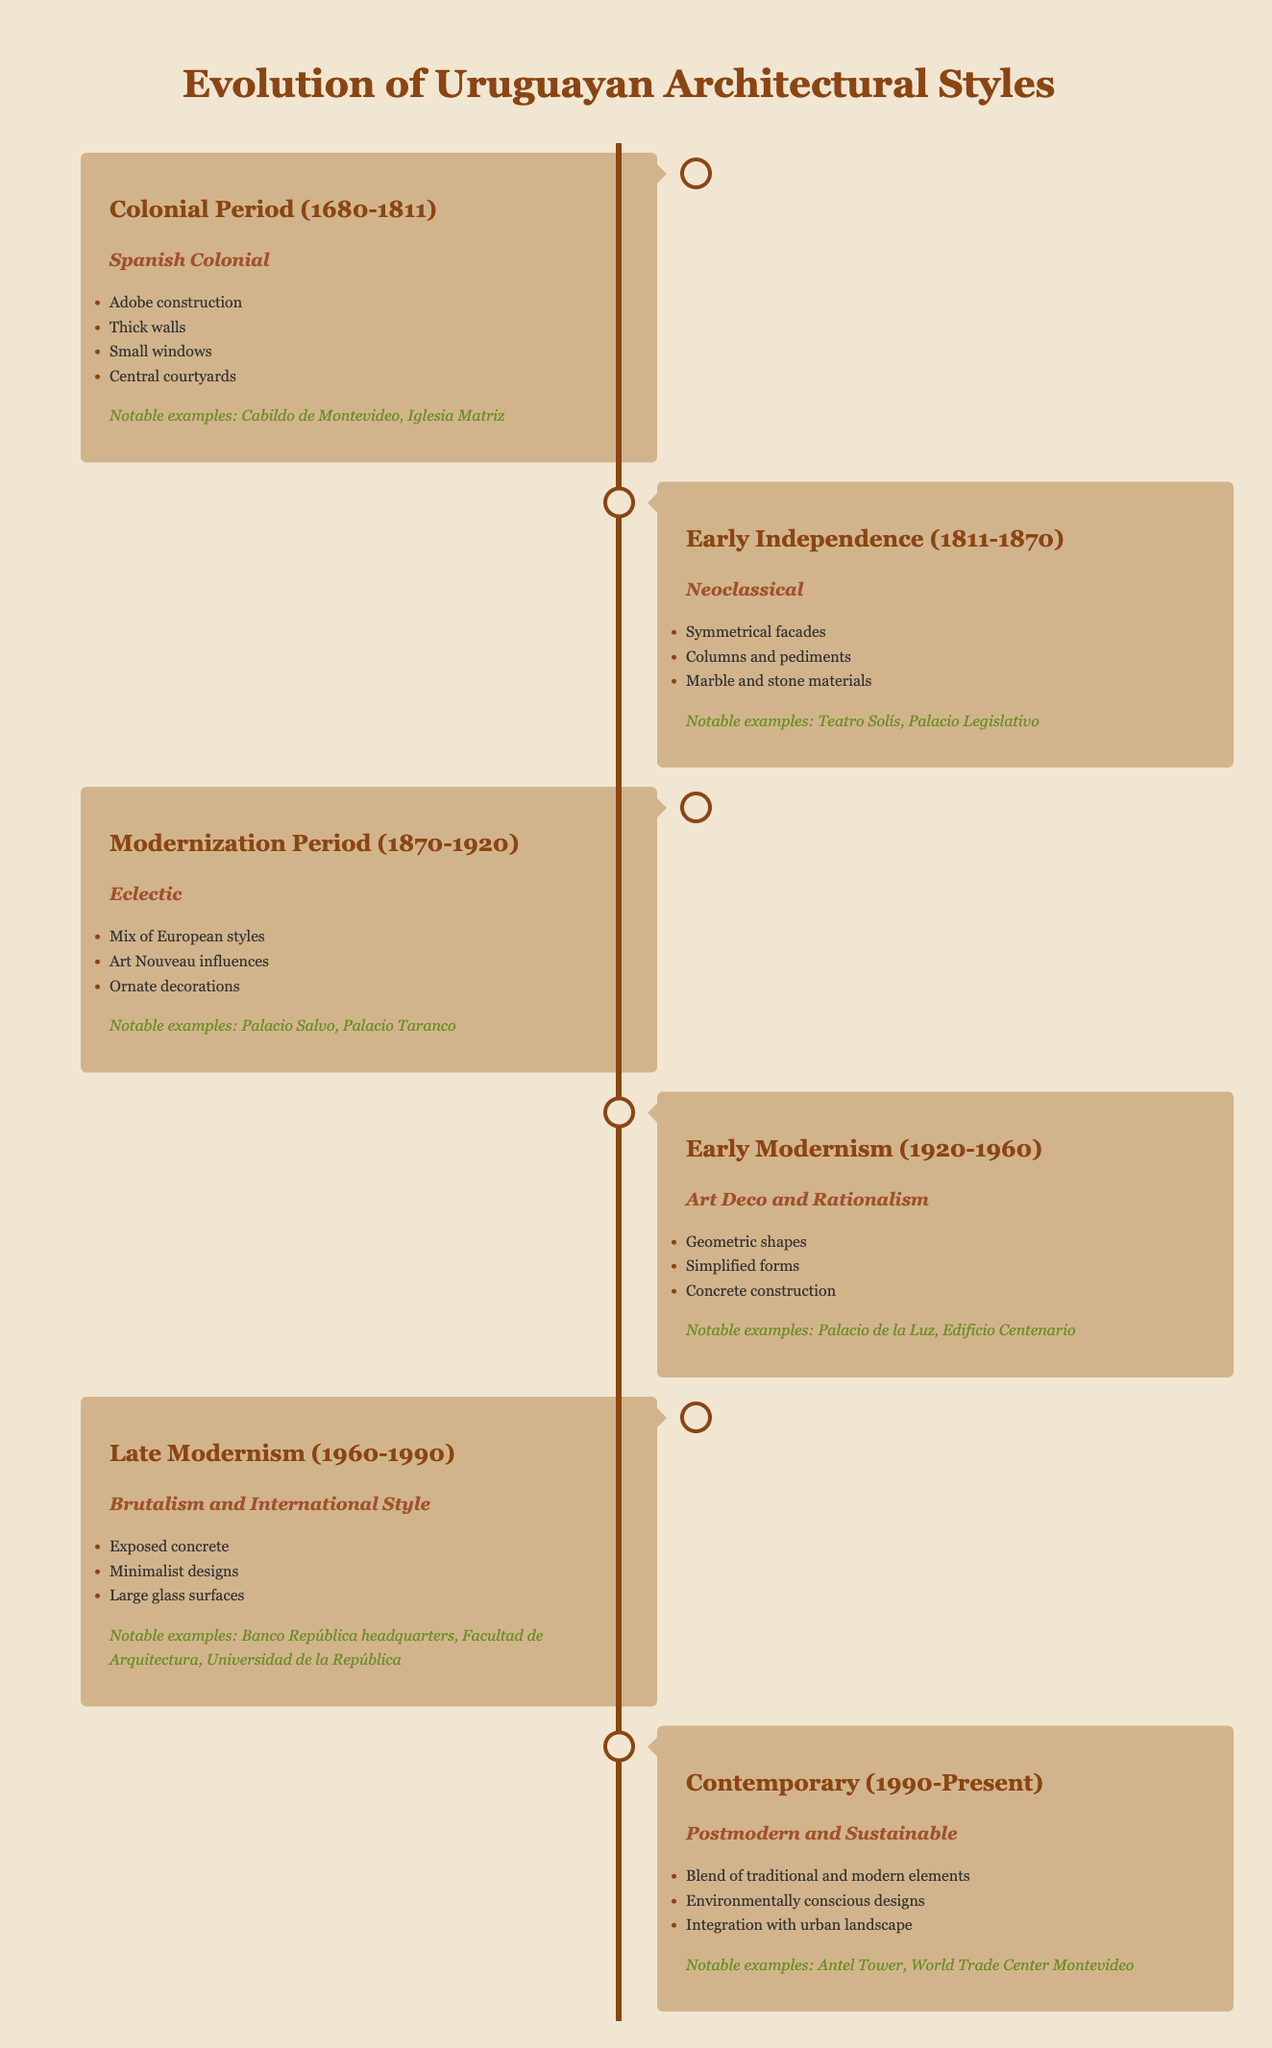What architectural style was prominent during the Colonial Period? The Colonial Period spans from 1680 to 1811, and the architectural style noted for this era is "Spanish Colonial" as specified in the table.
Answer: Spanish Colonial Which notable example belongs to the Early Independence era? The Early Independence era is from 1811 to 1870, and notable examples mentioned for this period are "Teatro Solís" and "Palacio Legislativo." Both are listed in the table under this era.
Answer: Teatro Solís and Palacio Legislativo What are two key features of the Modernization Period? The Modernization Period, which lasted from 1870 to 1920, is characterized by the "Eclectic" architectural style. Two key features noted in the table are "Mix of European styles" and "Art Nouveau influences." These can be directly referenced from the table.
Answer: Mix of European styles and Art Nouveau influences True or False: The architectural style during the Contemporary period is only characterized by traditional elements. The description of the Contemporary period (1990-Present) highlights a blend of traditional and modern elements, which indicates that the statement is incorrect. The table clearly states the integration of modern design concepts as well.
Answer: False What architectural styles emerged from 1920 to 1990, and how do they differ? From 1920 to 1960, the architectural style is "Art Deco and Rationalism," and from 1960 to 1990, it shifts to "Brutalism and International Style." The first focuses on geometric shapes and simplified forms, while the latter features exposed concrete and minimalist designs, indicating a transition from decoration to functionality. This comparison and the specific characteristics can be drawn from the table.
Answer: Art Deco and Rationalism, Brutalism and International Style How many architectural styles are associated with the Late Modernism period? The Late Modernism period (1960-1990) is singular in its architectural style, which is "Brutalism and International Style." The table shows a clear definition of the style for this specific timeframe.
Answer: One style: Brutalism and International Style List the notable examples from the Modernization Period and explain their relevance. The table notes "Palacio Salvo" and "Palacio Taranco" as notable examples from the Modernization Period (1870-1920). Both serve as significant representations of eclectic architecture and highlight the influence of various European styles within Uruguay’s architectural landscape.
Answer: Palacio Salvo and Palacio Taranco What was a significant change in architectural styles from the Early Modernism to Late Modernism periods? The transition from Early Modernism (1920-1960) with a focus on "Art Deco and Rationalism" featuring geometric designs to Late Modernism (1960-1990), which emphasized "Brutalism and International Style" showcasing exposed concrete and minimalist aesthetics signifies this shift toward functionality in design. The table clearly lays out both periods and their distinctive traits.
Answer: Shift from decorative styles to functional minimalist designs 